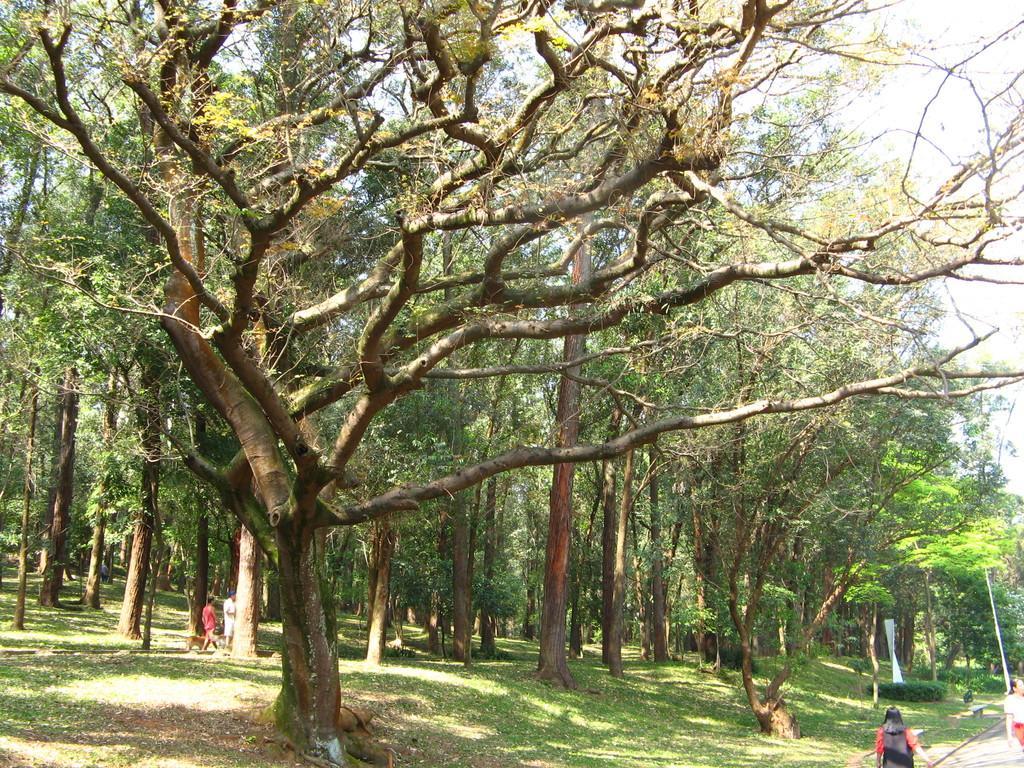Please provide a concise description of this image. There are two persons standing at the bottom of this image and there are two women standing in the bottom right corner of this image, and there are some trees as we can see in the middle of this image, and there is a sky in the background. 